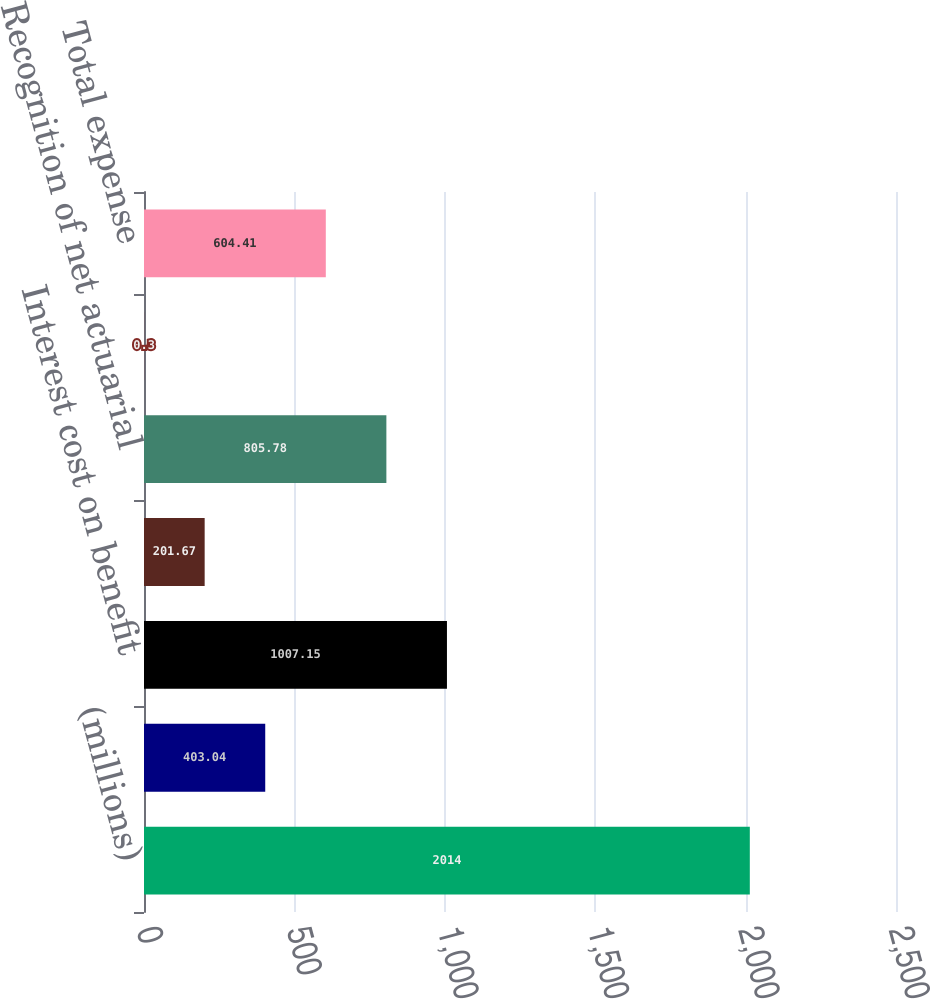Convert chart. <chart><loc_0><loc_0><loc_500><loc_500><bar_chart><fcel>(millions)<fcel>Service cost<fcel>Interest cost on benefit<fcel>Expected return on plan assets<fcel>Recognition of net actuarial<fcel>Amortization of prior service<fcel>Total expense<nl><fcel>2014<fcel>403.04<fcel>1007.15<fcel>201.67<fcel>805.78<fcel>0.3<fcel>604.41<nl></chart> 